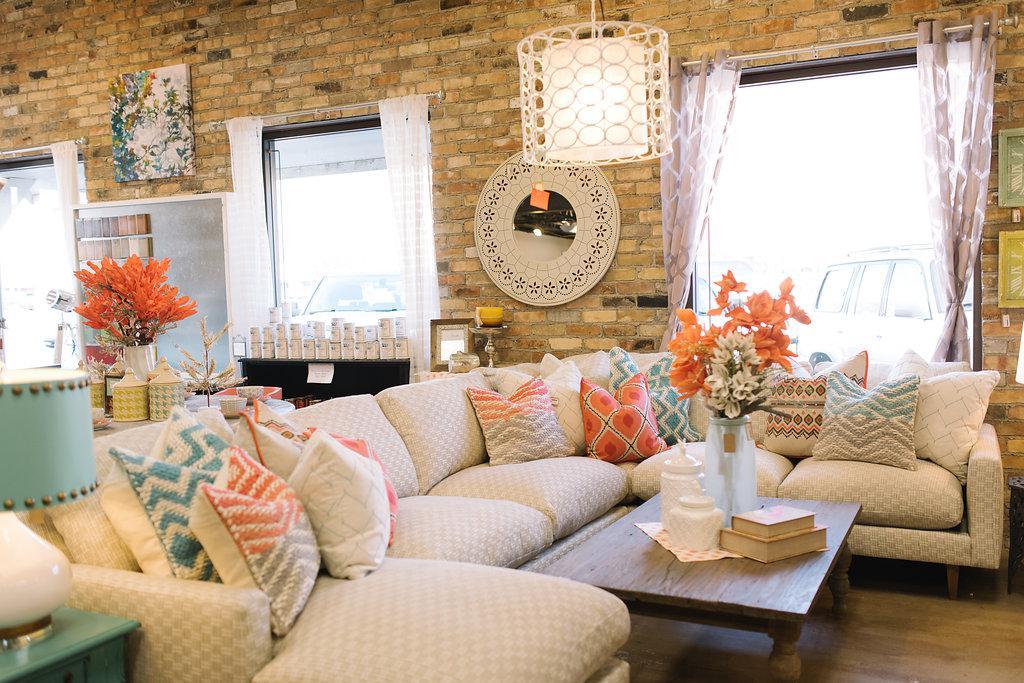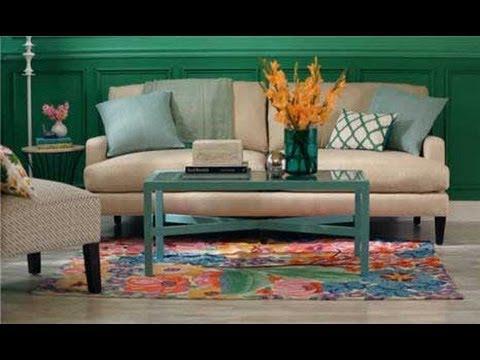The first image is the image on the left, the second image is the image on the right. Examine the images to the left and right. Is the description "The combined images include a solid green sofa, green cylindrical shape, green plant, and green printed pillows." accurate? Answer yes or no. No. The first image is the image on the left, the second image is the image on the right. Given the left and right images, does the statement "Both images show a vase of flowers sitting on top of a coffee table." hold true? Answer yes or no. Yes. 